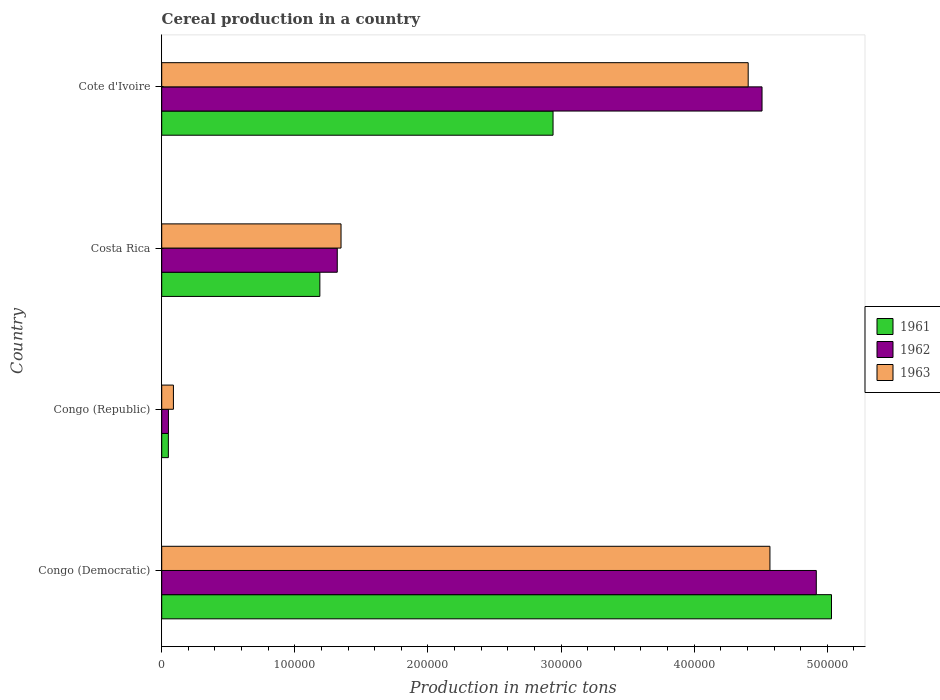How many different coloured bars are there?
Provide a short and direct response. 3. How many groups of bars are there?
Make the answer very short. 4. Are the number of bars on each tick of the Y-axis equal?
Offer a terse response. Yes. How many bars are there on the 4th tick from the top?
Offer a very short reply. 3. How many bars are there on the 3rd tick from the bottom?
Offer a very short reply. 3. What is the label of the 4th group of bars from the top?
Keep it short and to the point. Congo (Democratic). What is the total cereal production in 1961 in Cote d'Ivoire?
Your answer should be compact. 2.94e+05. Across all countries, what is the maximum total cereal production in 1962?
Your response must be concise. 4.92e+05. Across all countries, what is the minimum total cereal production in 1963?
Your answer should be very brief. 8800. In which country was the total cereal production in 1961 maximum?
Keep it short and to the point. Congo (Democratic). In which country was the total cereal production in 1962 minimum?
Give a very brief answer. Congo (Republic). What is the total total cereal production in 1961 in the graph?
Offer a very short reply. 9.21e+05. What is the difference between the total cereal production in 1962 in Congo (Democratic) and that in Cote d'Ivoire?
Give a very brief answer. 4.08e+04. What is the difference between the total cereal production in 1962 in Congo (Republic) and the total cereal production in 1963 in Congo (Democratic)?
Provide a short and direct response. -4.52e+05. What is the average total cereal production in 1963 per country?
Ensure brevity in your answer.  2.60e+05. What is the difference between the total cereal production in 1961 and total cereal production in 1962 in Costa Rica?
Your response must be concise. -1.31e+04. What is the ratio of the total cereal production in 1962 in Costa Rica to that in Cote d'Ivoire?
Offer a very short reply. 0.29. Is the total cereal production in 1961 in Congo (Republic) less than that in Cote d'Ivoire?
Keep it short and to the point. Yes. What is the difference between the highest and the second highest total cereal production in 1963?
Your response must be concise. 1.63e+04. What is the difference between the highest and the lowest total cereal production in 1961?
Your answer should be compact. 4.98e+05. What does the 1st bar from the top in Congo (Republic) represents?
Provide a succinct answer. 1963. How many bars are there?
Offer a very short reply. 12. How many countries are there in the graph?
Offer a very short reply. 4. Are the values on the major ticks of X-axis written in scientific E-notation?
Your answer should be compact. No. Does the graph contain grids?
Your response must be concise. No. How many legend labels are there?
Offer a terse response. 3. What is the title of the graph?
Your response must be concise. Cereal production in a country. Does "2005" appear as one of the legend labels in the graph?
Provide a succinct answer. No. What is the label or title of the X-axis?
Provide a short and direct response. Production in metric tons. What is the Production in metric tons in 1961 in Congo (Democratic)?
Ensure brevity in your answer.  5.03e+05. What is the Production in metric tons of 1962 in Congo (Democratic)?
Offer a very short reply. 4.92e+05. What is the Production in metric tons of 1963 in Congo (Democratic)?
Offer a terse response. 4.57e+05. What is the Production in metric tons in 1962 in Congo (Republic)?
Offer a terse response. 5050. What is the Production in metric tons in 1963 in Congo (Republic)?
Give a very brief answer. 8800. What is the Production in metric tons of 1961 in Costa Rica?
Ensure brevity in your answer.  1.19e+05. What is the Production in metric tons of 1962 in Costa Rica?
Make the answer very short. 1.32e+05. What is the Production in metric tons of 1963 in Costa Rica?
Give a very brief answer. 1.35e+05. What is the Production in metric tons of 1961 in Cote d'Ivoire?
Give a very brief answer. 2.94e+05. What is the Production in metric tons in 1962 in Cote d'Ivoire?
Your answer should be compact. 4.51e+05. What is the Production in metric tons of 1963 in Cote d'Ivoire?
Keep it short and to the point. 4.41e+05. Across all countries, what is the maximum Production in metric tons in 1961?
Provide a short and direct response. 5.03e+05. Across all countries, what is the maximum Production in metric tons in 1962?
Give a very brief answer. 4.92e+05. Across all countries, what is the maximum Production in metric tons of 1963?
Your response must be concise. 4.57e+05. Across all countries, what is the minimum Production in metric tons in 1962?
Offer a terse response. 5050. Across all countries, what is the minimum Production in metric tons of 1963?
Your response must be concise. 8800. What is the total Production in metric tons of 1961 in the graph?
Keep it short and to the point. 9.21e+05. What is the total Production in metric tons in 1962 in the graph?
Offer a terse response. 1.08e+06. What is the total Production in metric tons in 1963 in the graph?
Ensure brevity in your answer.  1.04e+06. What is the difference between the Production in metric tons in 1961 in Congo (Democratic) and that in Congo (Republic)?
Offer a terse response. 4.98e+05. What is the difference between the Production in metric tons in 1962 in Congo (Democratic) and that in Congo (Republic)?
Your answer should be very brief. 4.87e+05. What is the difference between the Production in metric tons of 1963 in Congo (Democratic) and that in Congo (Republic)?
Ensure brevity in your answer.  4.48e+05. What is the difference between the Production in metric tons of 1961 in Congo (Democratic) and that in Costa Rica?
Make the answer very short. 3.84e+05. What is the difference between the Production in metric tons in 1962 in Congo (Democratic) and that in Costa Rica?
Ensure brevity in your answer.  3.60e+05. What is the difference between the Production in metric tons in 1963 in Congo (Democratic) and that in Costa Rica?
Make the answer very short. 3.22e+05. What is the difference between the Production in metric tons in 1961 in Congo (Democratic) and that in Cote d'Ivoire?
Ensure brevity in your answer.  2.09e+05. What is the difference between the Production in metric tons in 1962 in Congo (Democratic) and that in Cote d'Ivoire?
Keep it short and to the point. 4.08e+04. What is the difference between the Production in metric tons in 1963 in Congo (Democratic) and that in Cote d'Ivoire?
Offer a very short reply. 1.63e+04. What is the difference between the Production in metric tons in 1961 in Congo (Republic) and that in Costa Rica?
Provide a succinct answer. -1.14e+05. What is the difference between the Production in metric tons in 1962 in Congo (Republic) and that in Costa Rica?
Your answer should be very brief. -1.27e+05. What is the difference between the Production in metric tons in 1963 in Congo (Republic) and that in Costa Rica?
Offer a terse response. -1.26e+05. What is the difference between the Production in metric tons of 1961 in Congo (Republic) and that in Cote d'Ivoire?
Provide a succinct answer. -2.89e+05. What is the difference between the Production in metric tons of 1962 in Congo (Republic) and that in Cote d'Ivoire?
Your answer should be compact. -4.46e+05. What is the difference between the Production in metric tons in 1963 in Congo (Republic) and that in Cote d'Ivoire?
Your response must be concise. -4.32e+05. What is the difference between the Production in metric tons of 1961 in Costa Rica and that in Cote d'Ivoire?
Your answer should be compact. -1.75e+05. What is the difference between the Production in metric tons in 1962 in Costa Rica and that in Cote d'Ivoire?
Offer a very short reply. -3.19e+05. What is the difference between the Production in metric tons of 1963 in Costa Rica and that in Cote d'Ivoire?
Make the answer very short. -3.06e+05. What is the difference between the Production in metric tons of 1961 in Congo (Democratic) and the Production in metric tons of 1962 in Congo (Republic)?
Offer a very short reply. 4.98e+05. What is the difference between the Production in metric tons of 1961 in Congo (Democratic) and the Production in metric tons of 1963 in Congo (Republic)?
Provide a succinct answer. 4.94e+05. What is the difference between the Production in metric tons in 1962 in Congo (Democratic) and the Production in metric tons in 1963 in Congo (Republic)?
Make the answer very short. 4.83e+05. What is the difference between the Production in metric tons in 1961 in Congo (Democratic) and the Production in metric tons in 1962 in Costa Rica?
Your answer should be compact. 3.71e+05. What is the difference between the Production in metric tons of 1961 in Congo (Democratic) and the Production in metric tons of 1963 in Costa Rica?
Offer a very short reply. 3.68e+05. What is the difference between the Production in metric tons of 1962 in Congo (Democratic) and the Production in metric tons of 1963 in Costa Rica?
Make the answer very short. 3.57e+05. What is the difference between the Production in metric tons in 1961 in Congo (Democratic) and the Production in metric tons in 1962 in Cote d'Ivoire?
Your answer should be compact. 5.22e+04. What is the difference between the Production in metric tons of 1961 in Congo (Democratic) and the Production in metric tons of 1963 in Cote d'Ivoire?
Offer a very short reply. 6.26e+04. What is the difference between the Production in metric tons of 1962 in Congo (Democratic) and the Production in metric tons of 1963 in Cote d'Ivoire?
Give a very brief answer. 5.12e+04. What is the difference between the Production in metric tons in 1961 in Congo (Republic) and the Production in metric tons in 1962 in Costa Rica?
Your answer should be compact. -1.27e+05. What is the difference between the Production in metric tons of 1961 in Congo (Republic) and the Production in metric tons of 1963 in Costa Rica?
Provide a short and direct response. -1.30e+05. What is the difference between the Production in metric tons in 1962 in Congo (Republic) and the Production in metric tons in 1963 in Costa Rica?
Your response must be concise. -1.30e+05. What is the difference between the Production in metric tons of 1961 in Congo (Republic) and the Production in metric tons of 1962 in Cote d'Ivoire?
Your answer should be very brief. -4.46e+05. What is the difference between the Production in metric tons in 1961 in Congo (Republic) and the Production in metric tons in 1963 in Cote d'Ivoire?
Make the answer very short. -4.36e+05. What is the difference between the Production in metric tons in 1962 in Congo (Republic) and the Production in metric tons in 1963 in Cote d'Ivoire?
Offer a terse response. -4.36e+05. What is the difference between the Production in metric tons of 1961 in Costa Rica and the Production in metric tons of 1962 in Cote d'Ivoire?
Ensure brevity in your answer.  -3.32e+05. What is the difference between the Production in metric tons in 1961 in Costa Rica and the Production in metric tons in 1963 in Cote d'Ivoire?
Give a very brief answer. -3.22e+05. What is the difference between the Production in metric tons of 1962 in Costa Rica and the Production in metric tons of 1963 in Cote d'Ivoire?
Provide a succinct answer. -3.09e+05. What is the average Production in metric tons in 1961 per country?
Your answer should be very brief. 2.30e+05. What is the average Production in metric tons of 1962 per country?
Provide a short and direct response. 2.70e+05. What is the average Production in metric tons in 1963 per country?
Offer a very short reply. 2.60e+05. What is the difference between the Production in metric tons in 1961 and Production in metric tons in 1962 in Congo (Democratic)?
Provide a succinct answer. 1.14e+04. What is the difference between the Production in metric tons in 1961 and Production in metric tons in 1963 in Congo (Democratic)?
Your response must be concise. 4.63e+04. What is the difference between the Production in metric tons of 1962 and Production in metric tons of 1963 in Congo (Democratic)?
Your response must be concise. 3.48e+04. What is the difference between the Production in metric tons of 1961 and Production in metric tons of 1963 in Congo (Republic)?
Make the answer very short. -3800. What is the difference between the Production in metric tons in 1962 and Production in metric tons in 1963 in Congo (Republic)?
Offer a terse response. -3750. What is the difference between the Production in metric tons in 1961 and Production in metric tons in 1962 in Costa Rica?
Keep it short and to the point. -1.31e+04. What is the difference between the Production in metric tons in 1961 and Production in metric tons in 1963 in Costa Rica?
Your answer should be compact. -1.59e+04. What is the difference between the Production in metric tons in 1962 and Production in metric tons in 1963 in Costa Rica?
Your answer should be compact. -2823. What is the difference between the Production in metric tons of 1961 and Production in metric tons of 1962 in Cote d'Ivoire?
Give a very brief answer. -1.57e+05. What is the difference between the Production in metric tons in 1961 and Production in metric tons in 1963 in Cote d'Ivoire?
Give a very brief answer. -1.47e+05. What is the difference between the Production in metric tons in 1962 and Production in metric tons in 1963 in Cote d'Ivoire?
Your response must be concise. 1.04e+04. What is the ratio of the Production in metric tons of 1961 in Congo (Democratic) to that in Congo (Republic)?
Your response must be concise. 100.64. What is the ratio of the Production in metric tons in 1962 in Congo (Democratic) to that in Congo (Republic)?
Offer a very short reply. 97.38. What is the ratio of the Production in metric tons of 1963 in Congo (Democratic) to that in Congo (Republic)?
Keep it short and to the point. 51.93. What is the ratio of the Production in metric tons in 1961 in Congo (Democratic) to that in Costa Rica?
Make the answer very short. 4.24. What is the ratio of the Production in metric tons of 1962 in Congo (Democratic) to that in Costa Rica?
Provide a succinct answer. 3.73. What is the ratio of the Production in metric tons in 1963 in Congo (Democratic) to that in Costa Rica?
Make the answer very short. 3.39. What is the ratio of the Production in metric tons of 1961 in Congo (Democratic) to that in Cote d'Ivoire?
Offer a terse response. 1.71. What is the ratio of the Production in metric tons in 1962 in Congo (Democratic) to that in Cote d'Ivoire?
Provide a succinct answer. 1.09. What is the ratio of the Production in metric tons in 1963 in Congo (Democratic) to that in Cote d'Ivoire?
Keep it short and to the point. 1.04. What is the ratio of the Production in metric tons of 1961 in Congo (Republic) to that in Costa Rica?
Provide a short and direct response. 0.04. What is the ratio of the Production in metric tons of 1962 in Congo (Republic) to that in Costa Rica?
Your answer should be compact. 0.04. What is the ratio of the Production in metric tons in 1963 in Congo (Republic) to that in Costa Rica?
Ensure brevity in your answer.  0.07. What is the ratio of the Production in metric tons of 1961 in Congo (Republic) to that in Cote d'Ivoire?
Offer a terse response. 0.02. What is the ratio of the Production in metric tons in 1962 in Congo (Republic) to that in Cote d'Ivoire?
Offer a terse response. 0.01. What is the ratio of the Production in metric tons of 1963 in Congo (Republic) to that in Cote d'Ivoire?
Offer a terse response. 0.02. What is the ratio of the Production in metric tons in 1961 in Costa Rica to that in Cote d'Ivoire?
Your response must be concise. 0.4. What is the ratio of the Production in metric tons of 1962 in Costa Rica to that in Cote d'Ivoire?
Ensure brevity in your answer.  0.29. What is the ratio of the Production in metric tons in 1963 in Costa Rica to that in Cote d'Ivoire?
Give a very brief answer. 0.31. What is the difference between the highest and the second highest Production in metric tons in 1961?
Offer a terse response. 2.09e+05. What is the difference between the highest and the second highest Production in metric tons of 1962?
Ensure brevity in your answer.  4.08e+04. What is the difference between the highest and the second highest Production in metric tons of 1963?
Provide a succinct answer. 1.63e+04. What is the difference between the highest and the lowest Production in metric tons in 1961?
Make the answer very short. 4.98e+05. What is the difference between the highest and the lowest Production in metric tons in 1962?
Make the answer very short. 4.87e+05. What is the difference between the highest and the lowest Production in metric tons of 1963?
Your answer should be compact. 4.48e+05. 